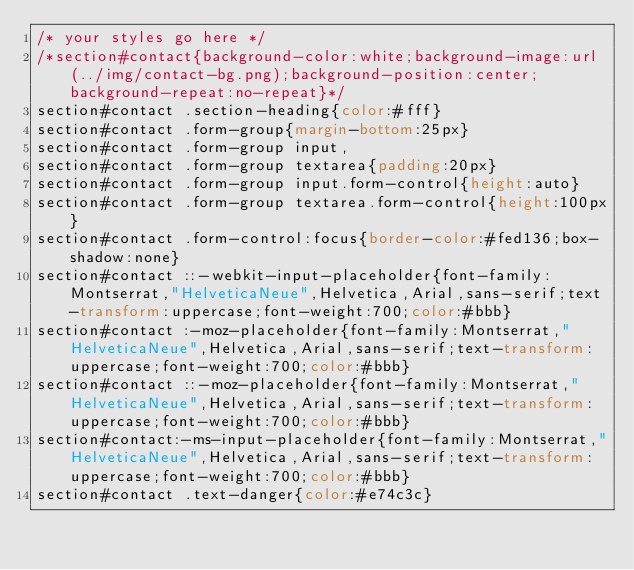Convert code to text. <code><loc_0><loc_0><loc_500><loc_500><_CSS_>/* your styles go here */
/*section#contact{background-color:white;background-image:url(../img/contact-bg.png);background-position:center;background-repeat:no-repeat}*/
section#contact .section-heading{color:#fff}
section#contact .form-group{margin-bottom:25px}
section#contact .form-group input,
section#contact .form-group textarea{padding:20px}
section#contact .form-group input.form-control{height:auto}
section#contact .form-group textarea.form-control{height:100px}
section#contact .form-control:focus{border-color:#fed136;box-shadow:none}
section#contact ::-webkit-input-placeholder{font-family:Montserrat,"HelveticaNeue",Helvetica,Arial,sans-serif;text-transform:uppercase;font-weight:700;color:#bbb}
section#contact :-moz-placeholder{font-family:Montserrat,"HelveticaNeue",Helvetica,Arial,sans-serif;text-transform:uppercase;font-weight:700;color:#bbb}
section#contact ::-moz-placeholder{font-family:Montserrat,"HelveticaNeue",Helvetica,Arial,sans-serif;text-transform:uppercase;font-weight:700;color:#bbb}
section#contact:-ms-input-placeholder{font-family:Montserrat,"HelveticaNeue",Helvetica,Arial,sans-serif;text-transform:uppercase;font-weight:700;color:#bbb}
section#contact .text-danger{color:#e74c3c}
</code> 